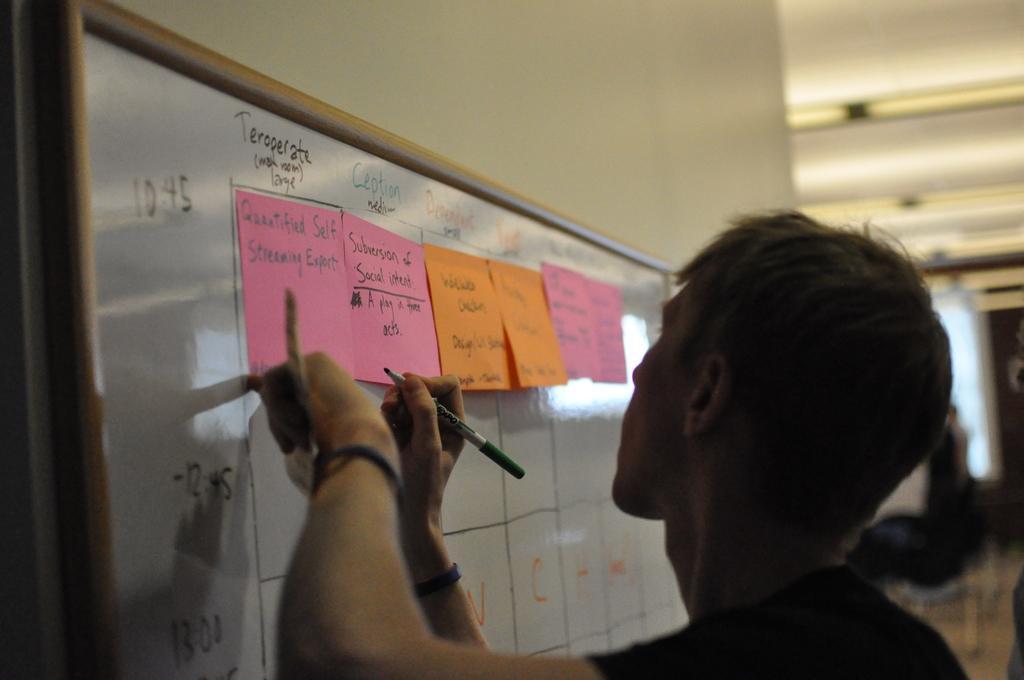Please provide a concise description of this image. In this image, we can see a person holding an object and a marker. In the background, we can see some papers pasted on the board and there are lights and some other objects. At the top, there is roof. 